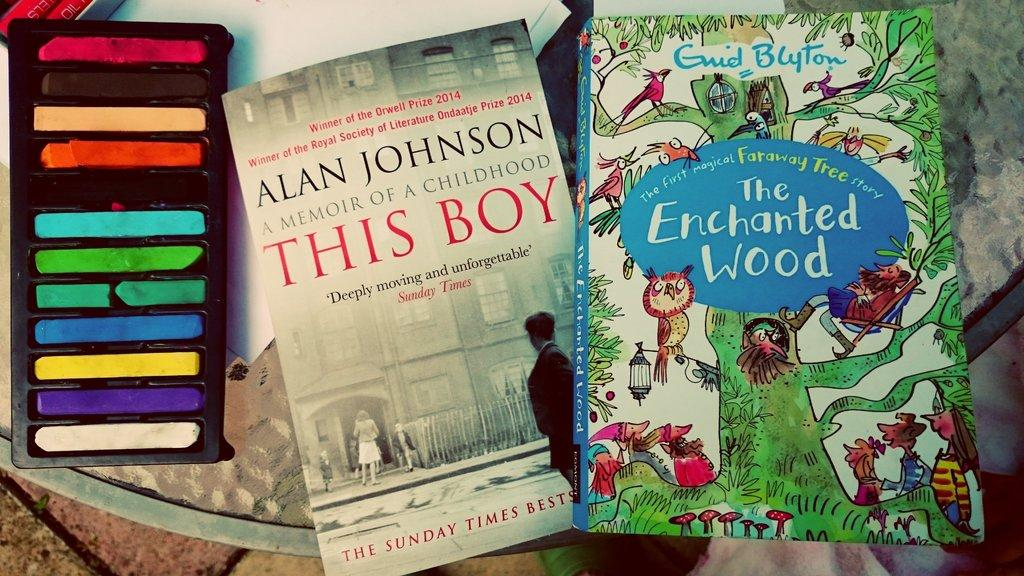<image>
Present a compact description of the photo's key features. Two books sit on a glass table, one of which is The Enchanted Wood. 